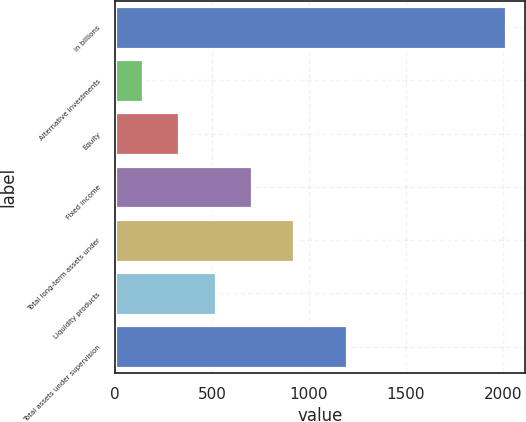Convert chart. <chart><loc_0><loc_0><loc_500><loc_500><bar_chart><fcel>in billions<fcel>Alternative investments<fcel>Equity<fcel>Fixed income<fcel>Total long-term assets under<fcel>Liquidity products<fcel>Total assets under supervision<nl><fcel>2015<fcel>145<fcel>332<fcel>706<fcel>922<fcel>519<fcel>1194<nl></chart> 